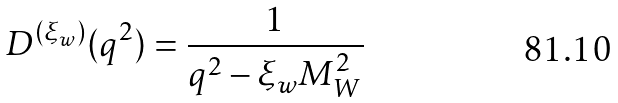<formula> <loc_0><loc_0><loc_500><loc_500>D ^ { ( \xi _ { w } ) } ( q ^ { 2 } ) = \frac { 1 } { q ^ { 2 } - \xi _ { w } M ^ { 2 } _ { W } }</formula> 